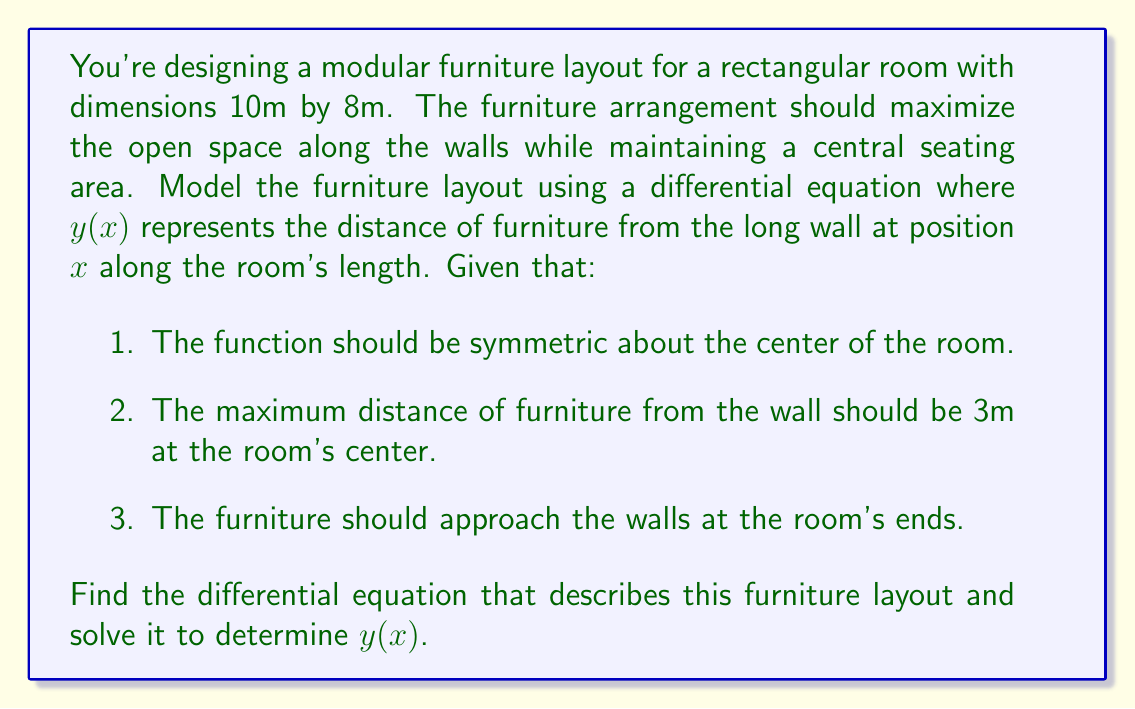Can you solve this math problem? Let's approach this problem step by step:

1) Given the symmetry requirement, we can model this with a function that peaks at the center of the room (x = 5m) and decreases towards both ends.

2) A suitable differential equation for this behavior is:

   $$\frac{d^2y}{dx^2} = -k^2y$$

   This is the equation for simple harmonic motion, where $k$ is a constant we need to determine.

3) The general solution to this differential equation is:

   $$y(x) = A \cos(kx) + B \sin(kx)$$

4) Given the symmetry about x = 5m, we can shift our coordinate system by 5m to simplify calculations. Let $u = x - 5$. Our solution becomes:

   $$y(u) = A \cos(ku) + B \sin(ku)$$

5) Applying the boundary conditions:
   - At u = 0 (center of room), y = 3m
   - At u = ±5m (ends of room), y should approach 0

6) The sine term disappears due to symmetry (B = 0), leaving us with:

   $$y(u) = A \cos(ku)$$

7) Applying the first condition: $3 = A \cos(0)$, so $A = 3$.

8) For the second condition, we want $\cos(5k)$ to be close to 0. The smallest positive value that satisfies this is when $5k = \frac{\pi}{2}$, or $k = \frac{\pi}{10}$.

9) Our final solution in terms of the original x-coordinate is:

   $$y(x) = 3 \cos(\frac{\pi}{10}(x-5))$$

This equation describes a furniture layout that meets all the given criteria, maximizing open space along the walls while maintaining a central seating area.
Answer: The differential equation describing the furniture layout is:

$$\frac{d^2y}{dx^2} = -(\frac{\pi}{10})^2y$$

And its solution, representing the distance of furniture from the long wall at position x, is:

$$y(x) = 3 \cos(\frac{\pi}{10}(x-5))$$ 